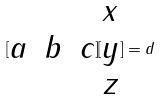Convert formula to latex. <formula><loc_0><loc_0><loc_500><loc_500>[ \begin{matrix} a & b & c \end{matrix} ] [ \begin{matrix} x \\ y \\ z \end{matrix} ] = d</formula> 